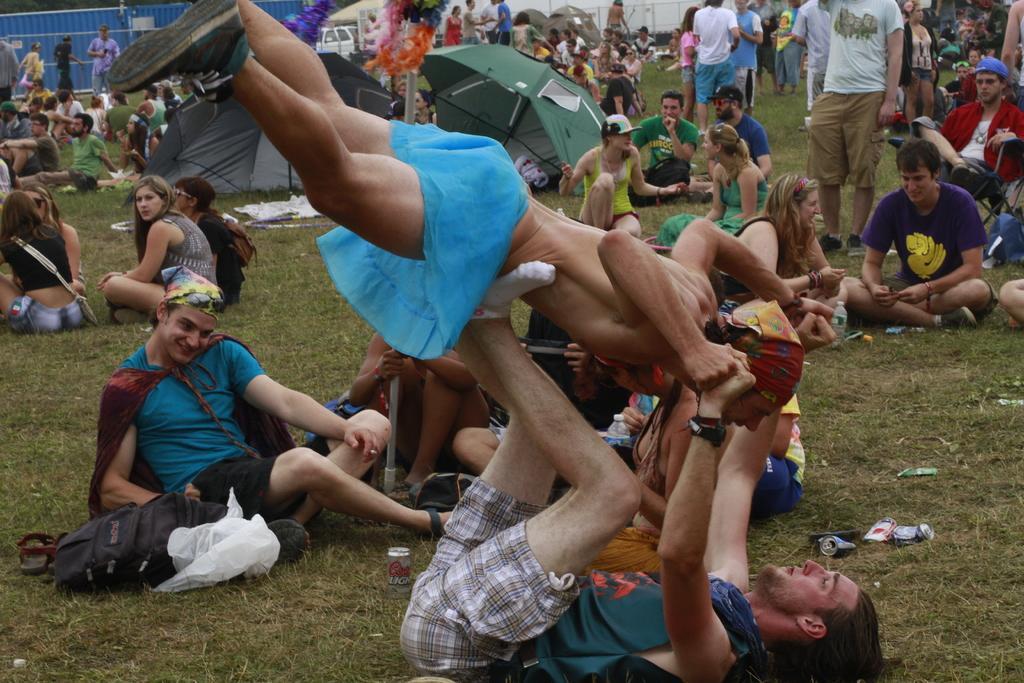How would you summarize this image in a sentence or two? In the picture we can see a grass surface on it, we can see a man laying and holding a person with legs and hands on top of him and behind him we can see some people are sitting in groups and talking to each other and some people are standing and talking and we can see a green color umbrella on the surface and in the background we can see a wall which is blue in color. 